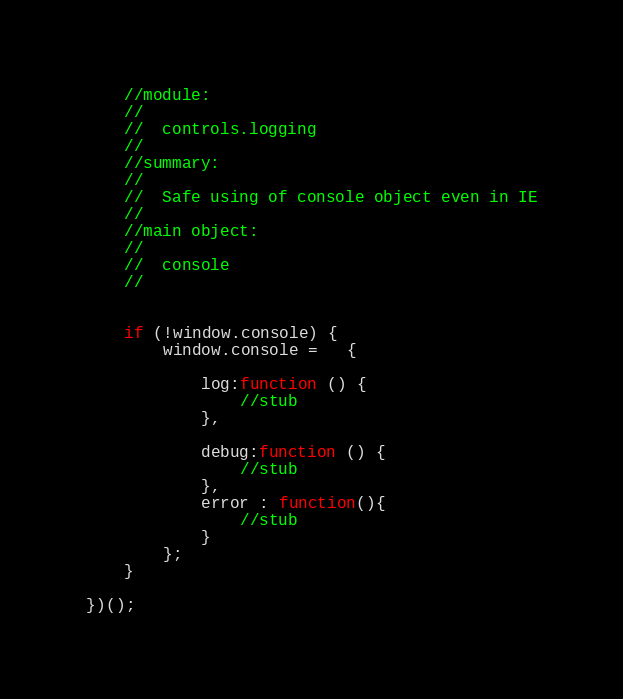Convert code to text. <code><loc_0><loc_0><loc_500><loc_500><_JavaScript_>    //module:
    //
    //  controls.logging
    //
    //summary:
    //
    //  Safe using of console object even in IE
    //
    //main object:
    //
    //  console
    //


    if (!window.console) {
        window.console =   {

            log:function () {
                //stub
            },

            debug:function () {
                //stub
            },
            error : function(){
                //stub
            }
        };
    }

})();</code> 